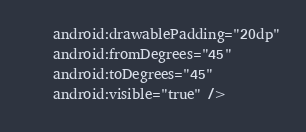Convert code to text. <code><loc_0><loc_0><loc_500><loc_500><_XML_>    android:drawablePadding="20dp"
    android:fromDegrees="45"
    android:toDegrees="45"
    android:visible="true" /></code> 